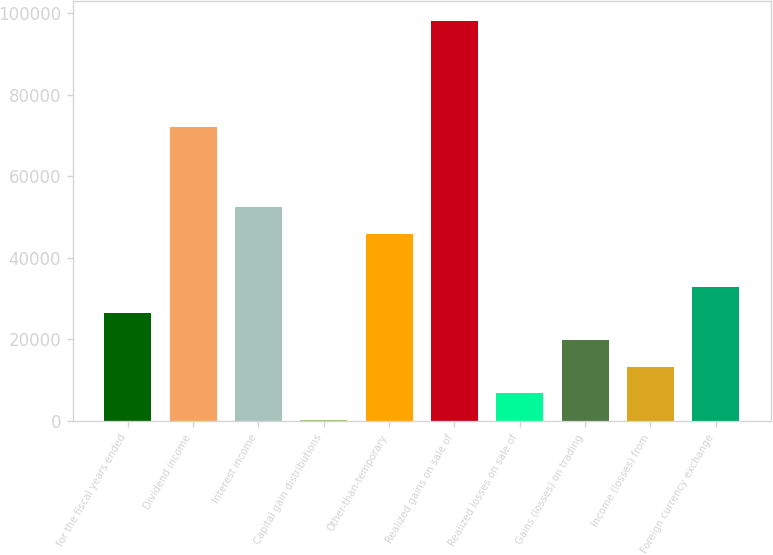Convert chart. <chart><loc_0><loc_0><loc_500><loc_500><bar_chart><fcel>for the fiscal years ended<fcel>Dividend income<fcel>Interest income<fcel>Capital gain distributions<fcel>Other-than-temporary<fcel>Realized gains on sale of<fcel>Realized losses on sale of<fcel>Gains (losses) on trading<fcel>Income (losses) from<fcel>Foreign currency exchange<nl><fcel>26366.8<fcel>72060.7<fcel>52477.6<fcel>256<fcel>45949.9<fcel>98171.5<fcel>6783.7<fcel>19839.1<fcel>13311.4<fcel>32894.5<nl></chart> 